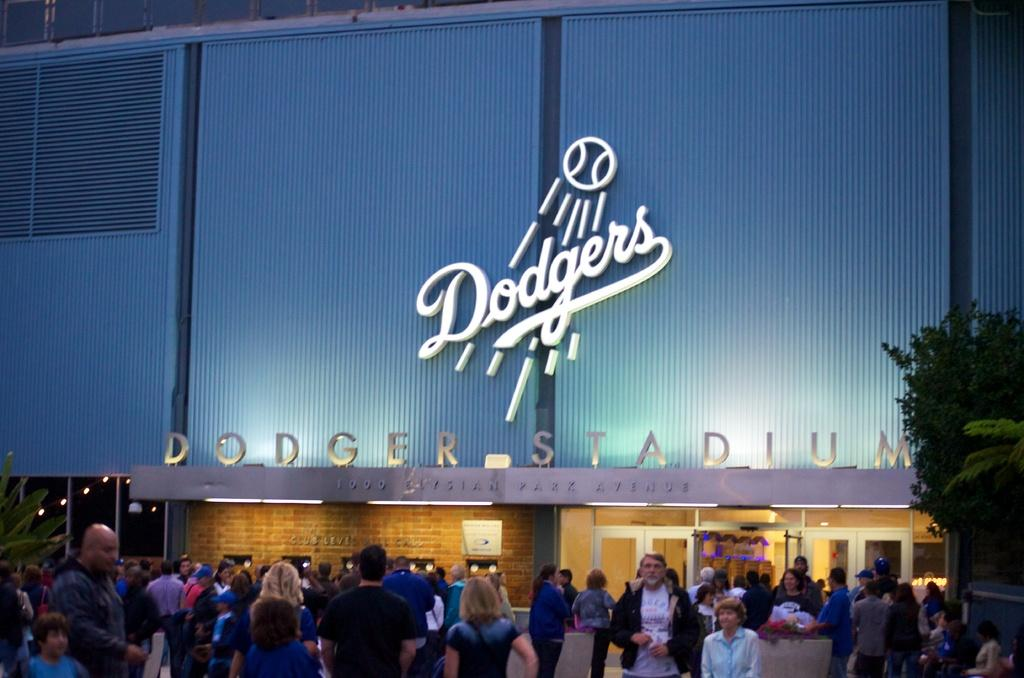What is happening in front of the building in the image? There are people standing in front of the building. What can be seen on the building itself? There is text on the building. What type of natural elements are present in the image? There are trees on both sides of the picture. What type of underwear is hanging from the trees in the image? There is no underwear present in the image; only people, a building, text, and trees are visible. What type of poison can be seen on the text of the building? There is no poison mentioned or visible in the image; only text is present on the building. 